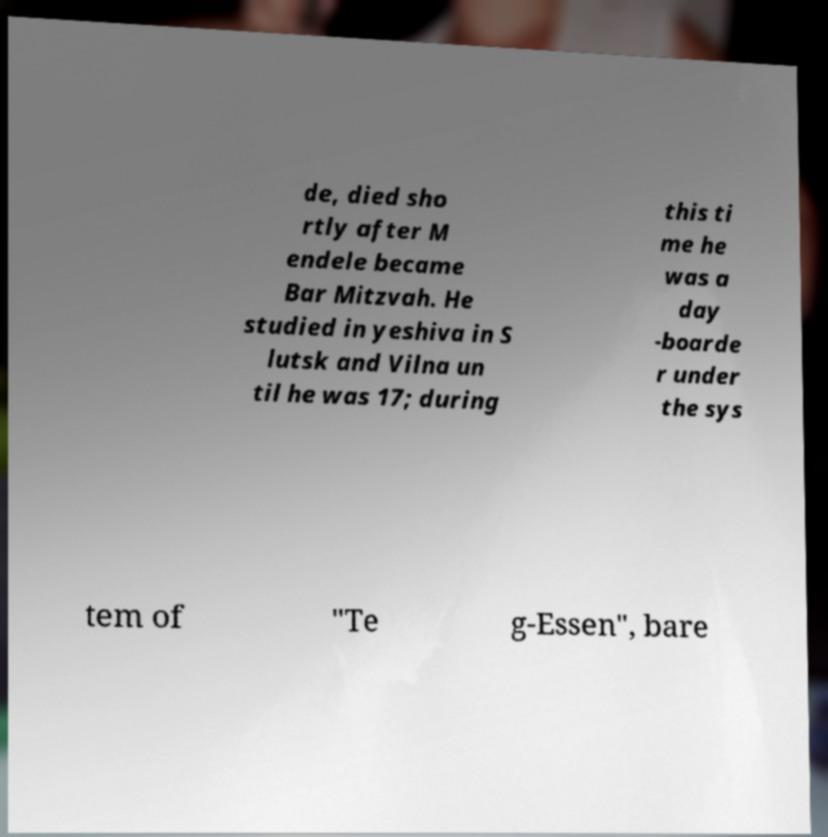Can you read and provide the text displayed in the image?This photo seems to have some interesting text. Can you extract and type it out for me? de, died sho rtly after M endele became Bar Mitzvah. He studied in yeshiva in S lutsk and Vilna un til he was 17; during this ti me he was a day -boarde r under the sys tem of "Te g-Essen", bare 